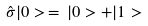Convert formula to latex. <formula><loc_0><loc_0><loc_500><loc_500>\hat { \sigma } | 0 > \, = \, | 0 > + | 1 ></formula> 